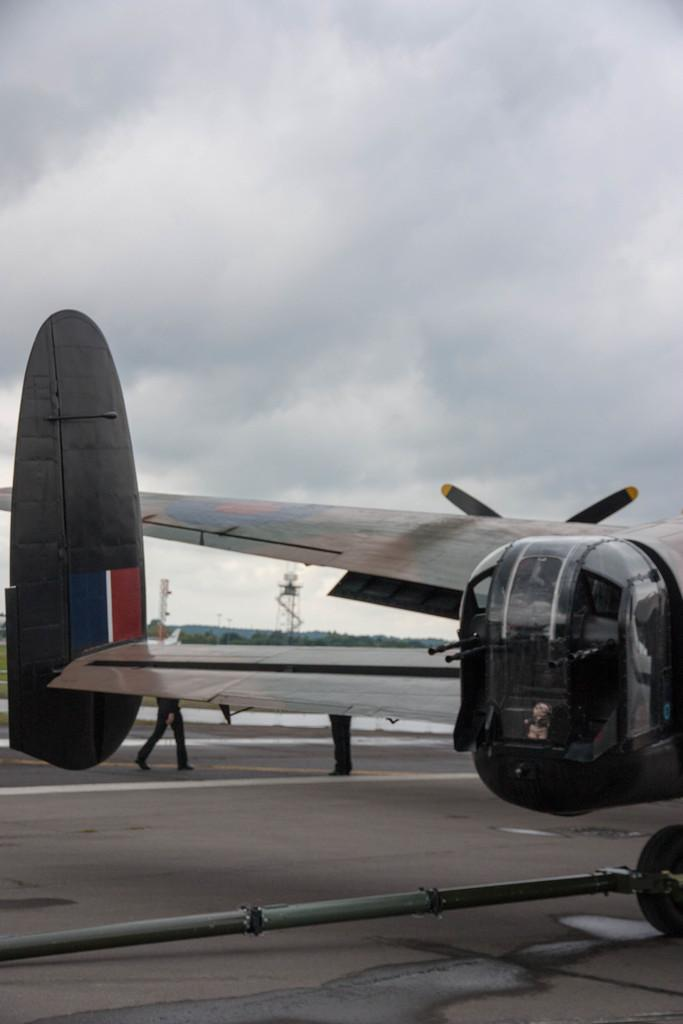What is the main subject of the picture? The main subject of the picture is a plane. Can you describe the position of the people in the image? Two people's legs are on the ground in the image. What can be seen in the background of the picture? There are trees, towers, and the sky visible in the background of the picture. What is the purpose of the swing in the image? There is no swing present in the image. 